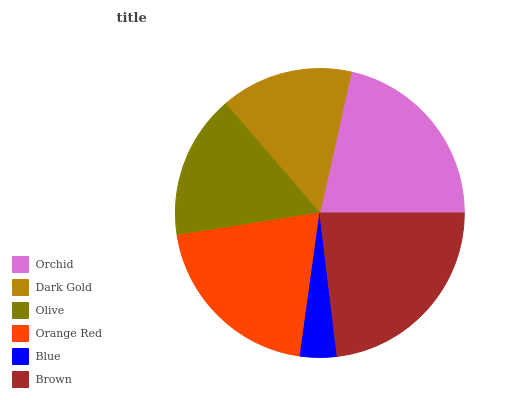Is Blue the minimum?
Answer yes or no. Yes. Is Brown the maximum?
Answer yes or no. Yes. Is Dark Gold the minimum?
Answer yes or no. No. Is Dark Gold the maximum?
Answer yes or no. No. Is Orchid greater than Dark Gold?
Answer yes or no. Yes. Is Dark Gold less than Orchid?
Answer yes or no. Yes. Is Dark Gold greater than Orchid?
Answer yes or no. No. Is Orchid less than Dark Gold?
Answer yes or no. No. Is Orange Red the high median?
Answer yes or no. Yes. Is Olive the low median?
Answer yes or no. Yes. Is Blue the high median?
Answer yes or no. No. Is Blue the low median?
Answer yes or no. No. 